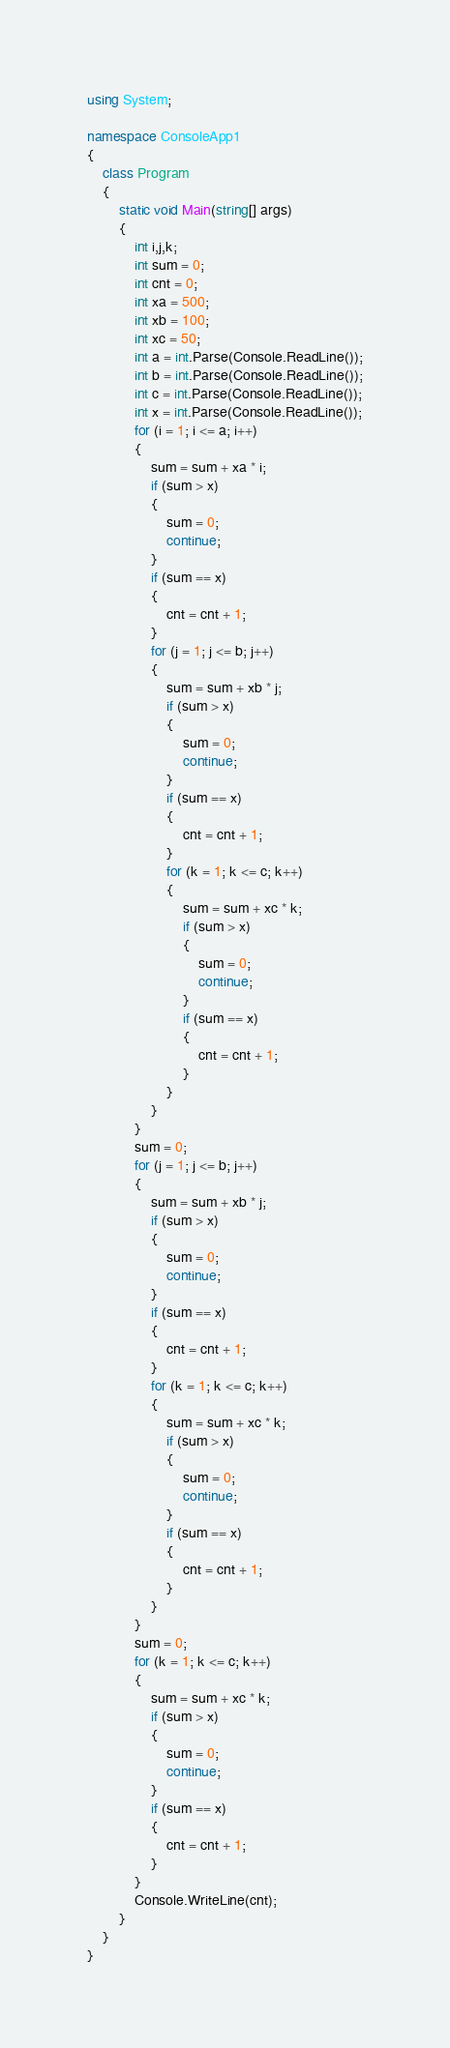Convert code to text. <code><loc_0><loc_0><loc_500><loc_500><_C#_>using System;

namespace ConsoleApp1
{
    class Program
    {
        static void Main(string[] args)
        {
            int i,j,k;
            int sum = 0;
            int cnt = 0;
            int xa = 500;
            int xb = 100;
            int xc = 50;
            int a = int.Parse(Console.ReadLine());
            int b = int.Parse(Console.ReadLine());
            int c = int.Parse(Console.ReadLine());
            int x = int.Parse(Console.ReadLine());
            for (i = 1; i <= a; i++)
            {               
                sum = sum + xa * i;
                if (sum > x)
                {
                    sum = 0;
                    continue;
                }
                if (sum == x)
                {
                    cnt = cnt + 1;
                }
                for (j = 1; j <= b; j++)
                {
                    sum = sum + xb * j;
                    if (sum > x)
                    {
                        sum = 0;
                        continue;
                    }
                    if (sum == x)
                    {
                        cnt = cnt + 1;
                    }
                    for (k = 1; k <= c; k++)
                    {
                        sum = sum + xc * k;
                        if (sum > x)
                        {
                            sum = 0;
                            continue;
                        }
                        if (sum == x)
                        {
                            cnt = cnt + 1;
                        }
                    }
                }
            }
            sum = 0;
            for (j = 1; j <= b; j++)
            {
                sum = sum + xb * j;
                if (sum > x)
                {
                    sum = 0;
                    continue;
                }
                if (sum == x)
                {
                    cnt = cnt + 1;
                }
                for (k = 1; k <= c; k++)
                {
                    sum = sum + xc * k;
                    if (sum > x)
                    {
                        sum = 0;
                        continue;
                    }
                    if (sum == x)
                    {
                        cnt = cnt + 1;
                    }
                }
            }
            sum = 0;
            for (k = 1; k <= c; k++)
            {
                sum = sum + xc * k;
                if (sum > x)
                {
                    sum = 0;
                    continue;
                }
                if (sum == x)
                {
                    cnt = cnt + 1;
                }
            }
            Console.WriteLine(cnt);
        }
    }
}
</code> 